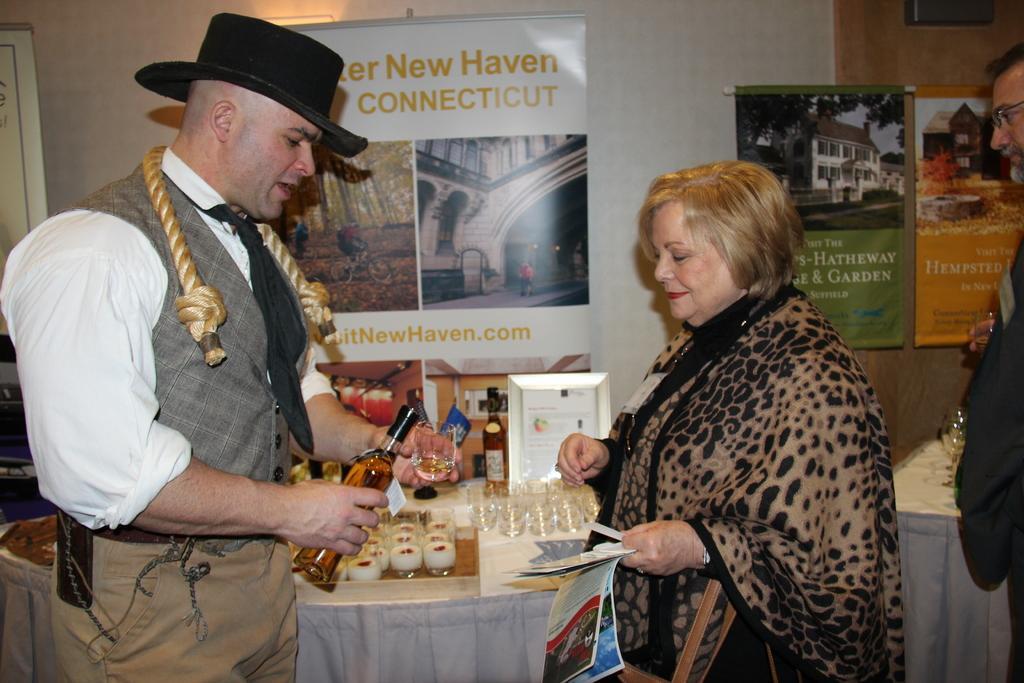How would you summarize this image in a sentence or two? there is a man and woman standing each other A man is holding a bottle there is a table on the table there are different items 